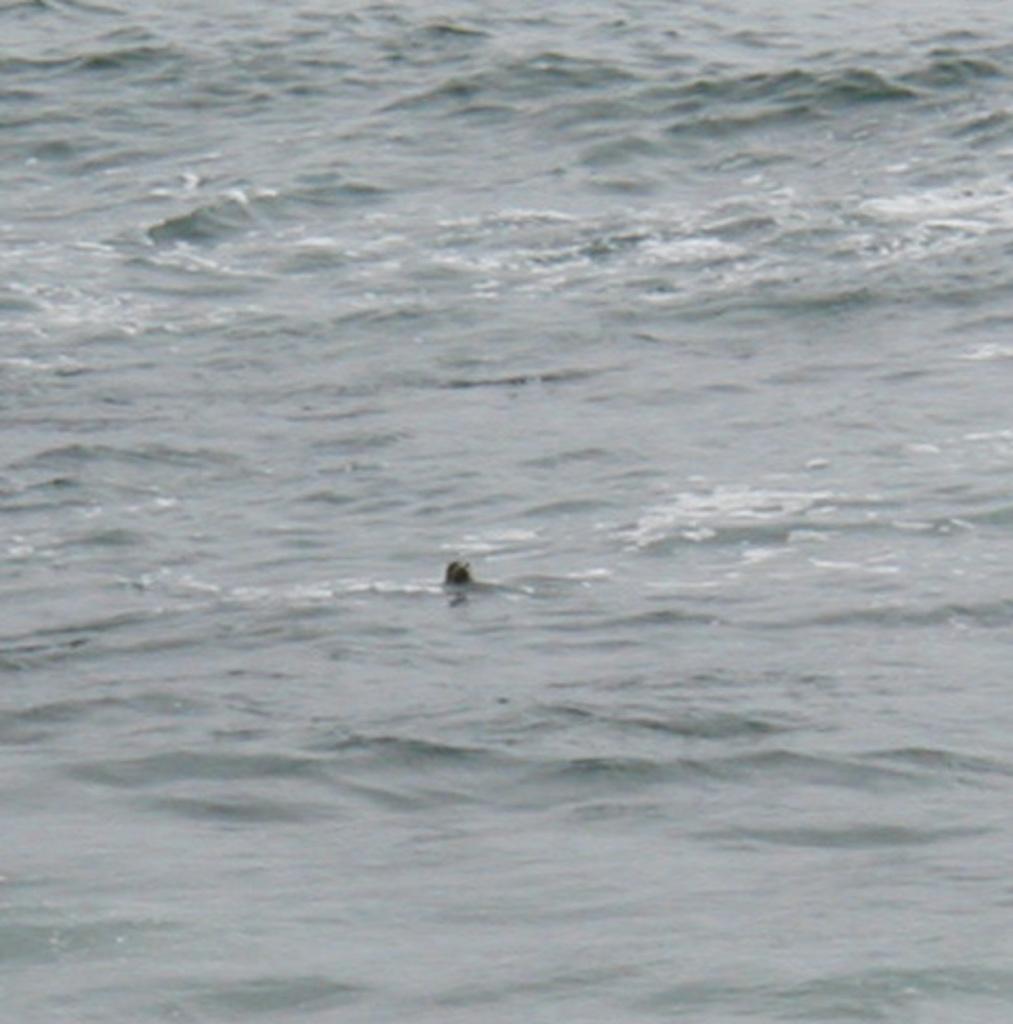How would you summarize this image in a sentence or two? In this picture we can observe something in the water. In the background there is a water. 